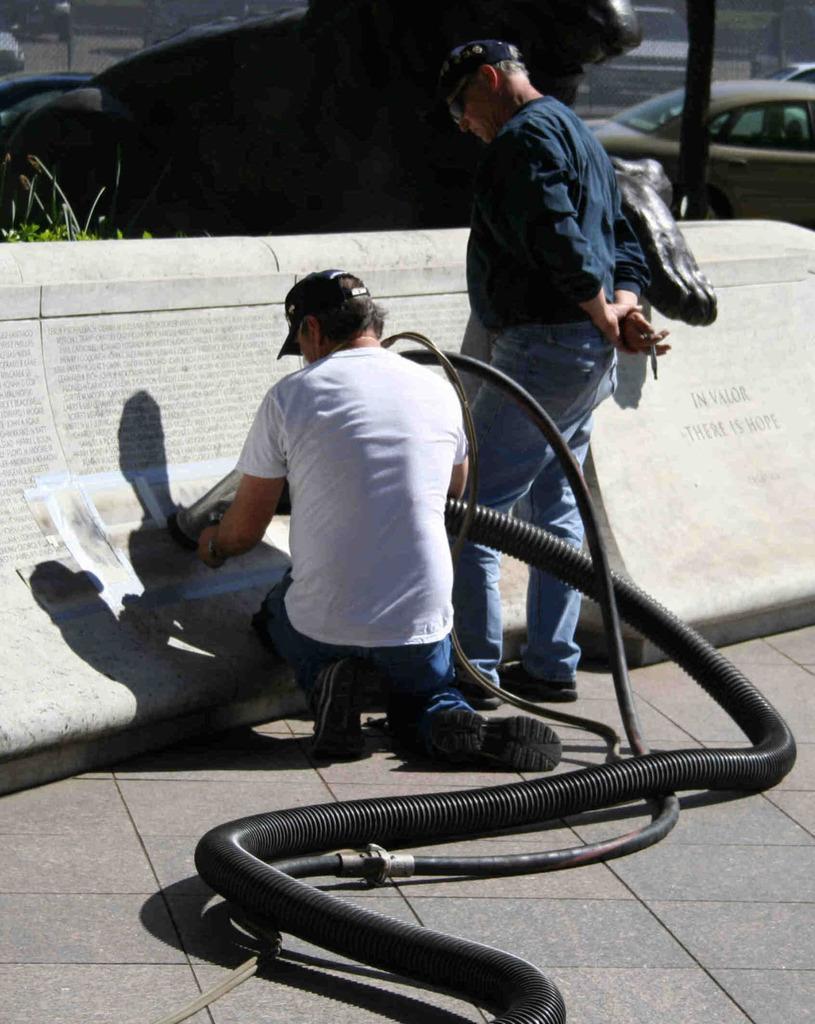Could you give a brief overview of what you see in this image? In this image, at the middle we can see man holding a black color cable, there is a man standing and he is looking at the wall, in the background we can see a car. 